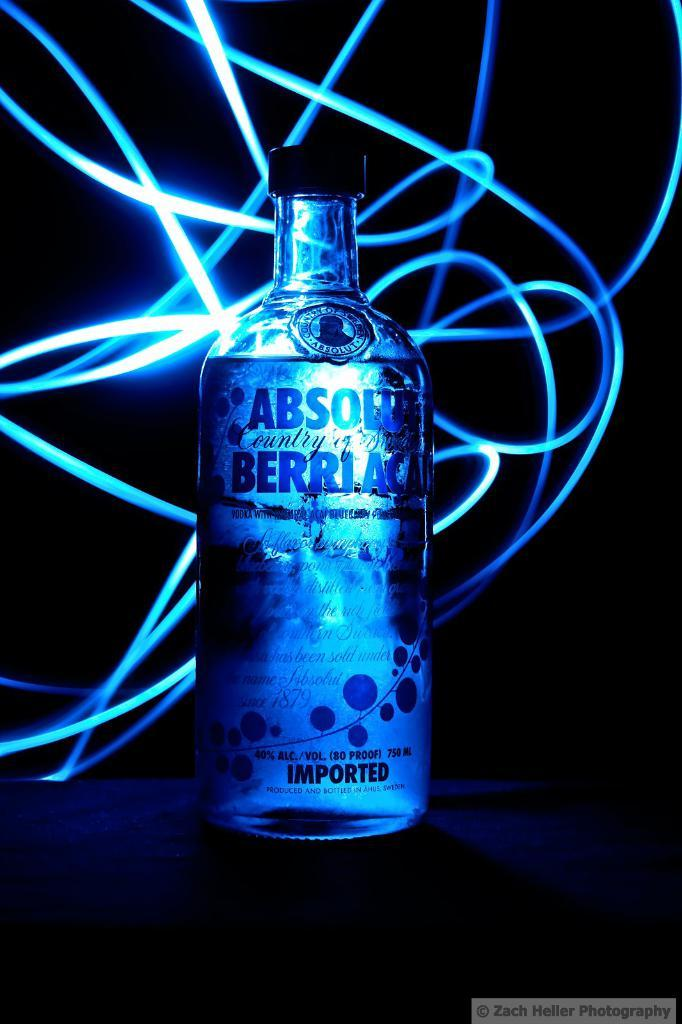Provide a one-sentence caption for the provided image. a back lit ad for Absolut Berriac Imported liquor. 